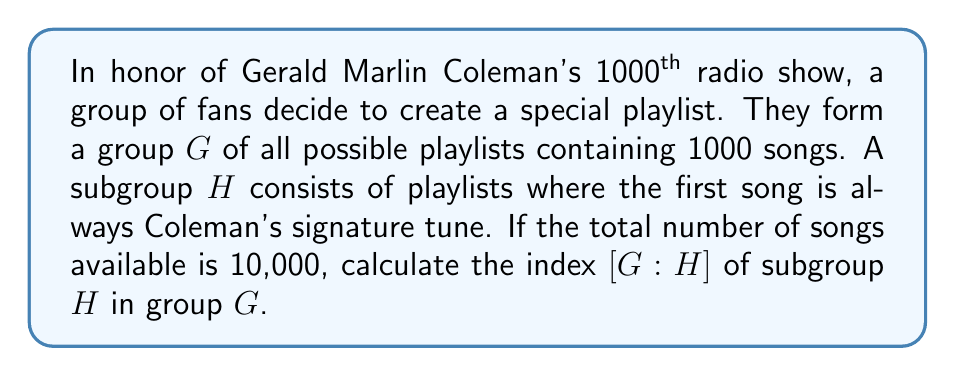Show me your answer to this math problem. Let's approach this step-by-step:

1) First, we need to understand what the index represents. The index $[G:H]$ is the number of distinct left (or right) cosets of $H$ in $G$, which is also equal to $\frac{|G|}{|H|}$ where $|G|$ and $|H|$ are the orders (sizes) of $G$ and $H$ respectively.

2) To find $|G|$:
   - We have 10,000 choices for each of the 1000 songs in the playlist.
   - Therefore, $|G| = 10000^{1000}$

3) To find $|H|$:
   - The first song is fixed, so we only have choices for the remaining 999 songs.
   - We have 10,000 choices for each of these 999 songs.
   - Therefore, $|H| = 10000^{999}$

4) Now we can calculate the index:

   $$[G:H] = \frac{|G|}{|H|} = \frac{10000^{1000}}{10000^{999}} = 10000$$

5) This makes sense intuitively: the index represents how many ways we can choose the first song, which is indeed 10,000.
Answer: 10000 